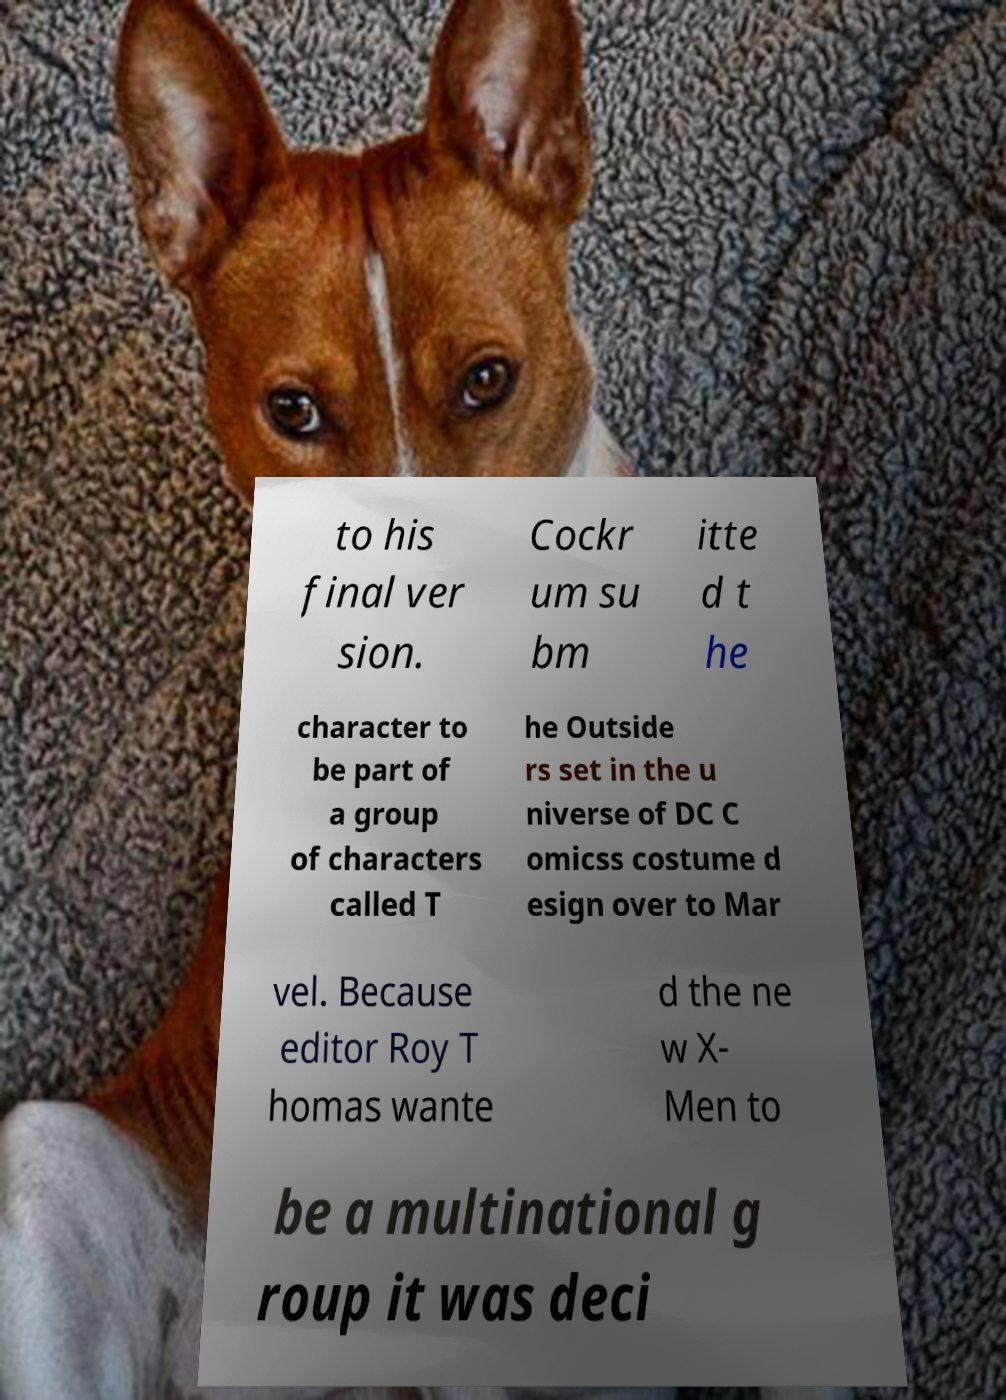Can you read and provide the text displayed in the image?This photo seems to have some interesting text. Can you extract and type it out for me? to his final ver sion. Cockr um su bm itte d t he character to be part of a group of characters called T he Outside rs set in the u niverse of DC C omicss costume d esign over to Mar vel. Because editor Roy T homas wante d the ne w X- Men to be a multinational g roup it was deci 